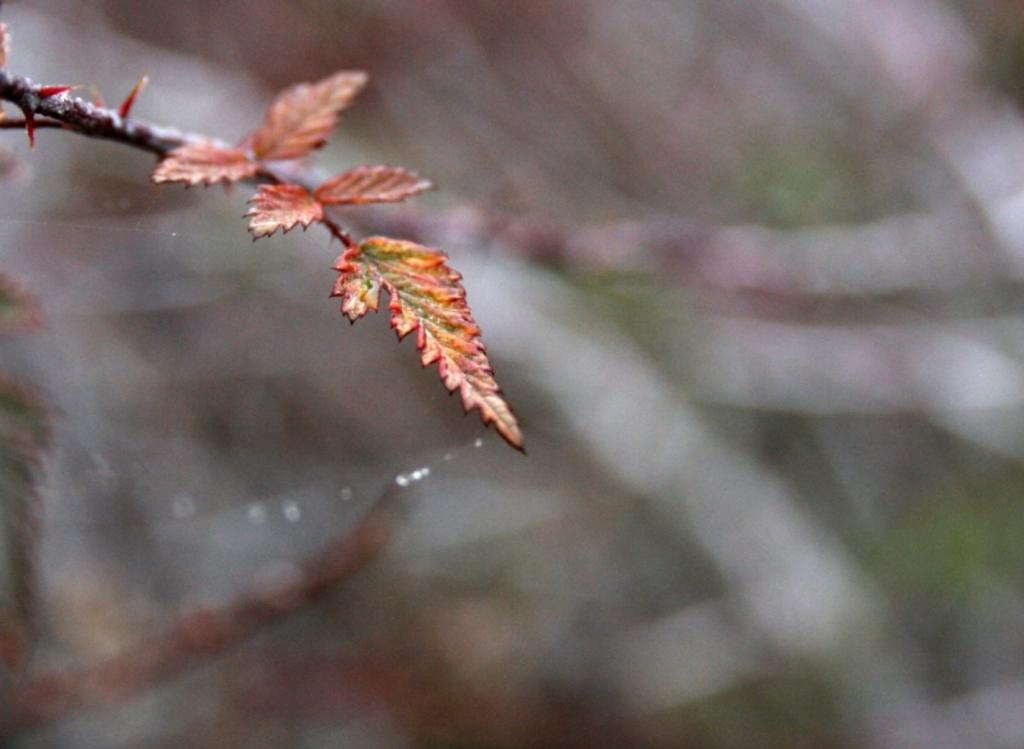What is present in the image? There is a plant in the image. Can you describe the colors of the plant? The plant has orange, green, and yellow colors. How would you describe the background of the image? The background of the image is blurry. How many units of beetles can be seen walking in the image? There are no beetles present in the image, so it is not possible to determine the number of units or their movement. 